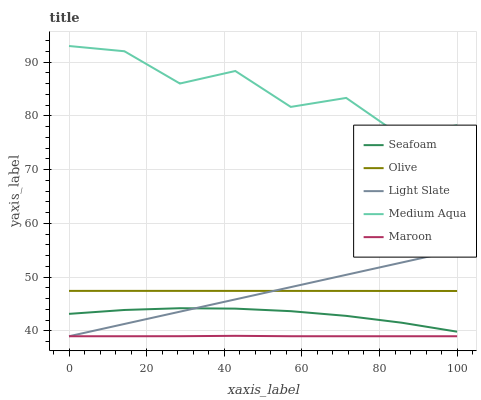Does Maroon have the minimum area under the curve?
Answer yes or no. Yes. Does Medium Aqua have the maximum area under the curve?
Answer yes or no. Yes. Does Light Slate have the minimum area under the curve?
Answer yes or no. No. Does Light Slate have the maximum area under the curve?
Answer yes or no. No. Is Light Slate the smoothest?
Answer yes or no. Yes. Is Medium Aqua the roughest?
Answer yes or no. Yes. Is Medium Aqua the smoothest?
Answer yes or no. No. Is Light Slate the roughest?
Answer yes or no. No. Does Light Slate have the lowest value?
Answer yes or no. Yes. Does Medium Aqua have the lowest value?
Answer yes or no. No. Does Medium Aqua have the highest value?
Answer yes or no. Yes. Does Light Slate have the highest value?
Answer yes or no. No. Is Maroon less than Medium Aqua?
Answer yes or no. Yes. Is Medium Aqua greater than Olive?
Answer yes or no. Yes. Does Maroon intersect Light Slate?
Answer yes or no. Yes. Is Maroon less than Light Slate?
Answer yes or no. No. Is Maroon greater than Light Slate?
Answer yes or no. No. Does Maroon intersect Medium Aqua?
Answer yes or no. No. 